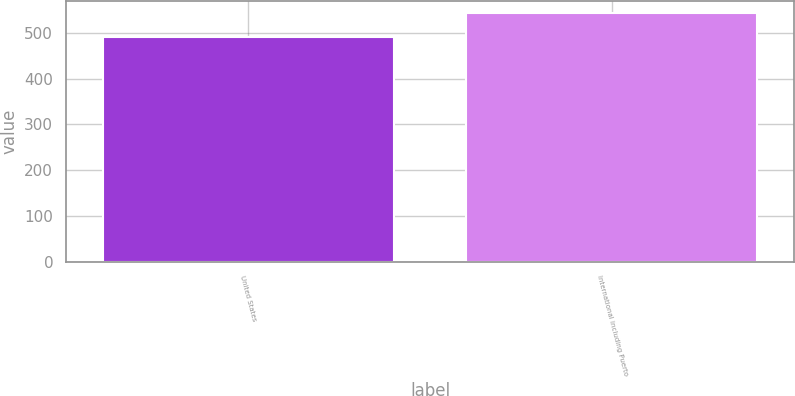<chart> <loc_0><loc_0><loc_500><loc_500><bar_chart><fcel>United States<fcel>International including Puerto<nl><fcel>491.5<fcel>543.4<nl></chart> 